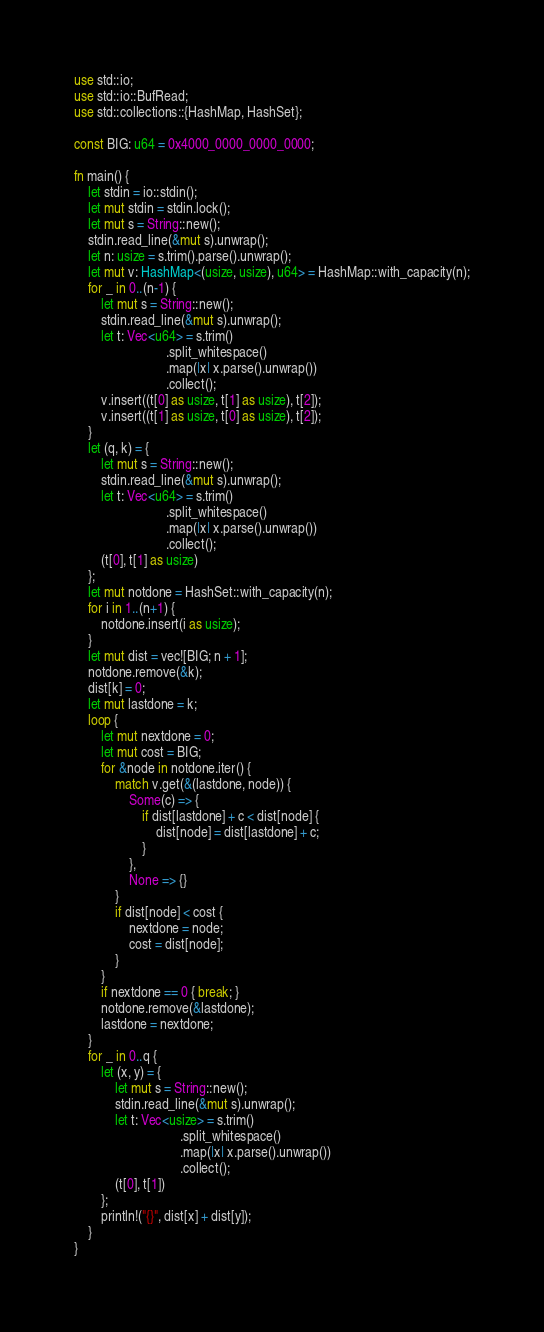Convert code to text. <code><loc_0><loc_0><loc_500><loc_500><_Rust_>use std::io;
use std::io::BufRead;
use std::collections::{HashMap, HashSet};

const BIG: u64 = 0x4000_0000_0000_0000;

fn main() {
    let stdin = io::stdin();
    let mut stdin = stdin.lock();
    let mut s = String::new();
    stdin.read_line(&mut s).unwrap();
    let n: usize = s.trim().parse().unwrap();
    let mut v: HashMap<(usize, usize), u64> = HashMap::with_capacity(n);
    for _ in 0..(n-1) {
        let mut s = String::new();
        stdin.read_line(&mut s).unwrap();
        let t: Vec<u64> = s.trim()
                           .split_whitespace()
                           .map(|x| x.parse().unwrap())
                           .collect();
        v.insert((t[0] as usize, t[1] as usize), t[2]);
        v.insert((t[1] as usize, t[0] as usize), t[2]);
    }
    let (q, k) = {
        let mut s = String::new();
        stdin.read_line(&mut s).unwrap();
        let t: Vec<u64> = s.trim()
                           .split_whitespace()
                           .map(|x| x.parse().unwrap())
                           .collect();
        (t[0], t[1] as usize)
    };
    let mut notdone = HashSet::with_capacity(n);
    for i in 1..(n+1) {
        notdone.insert(i as usize);
    }
    let mut dist = vec![BIG; n + 1];
    notdone.remove(&k);
    dist[k] = 0;
    let mut lastdone = k;
    loop {
        let mut nextdone = 0;
        let mut cost = BIG;
        for &node in notdone.iter() {
            match v.get(&(lastdone, node)) {
                Some(c) => {
                    if dist[lastdone] + c < dist[node] {
                        dist[node] = dist[lastdone] + c;
                    }
                },
                None => {}
            }
            if dist[node] < cost {
                nextdone = node;
                cost = dist[node];
            }
        }
        if nextdone == 0 { break; }
        notdone.remove(&lastdone);
        lastdone = nextdone;
    }
    for _ in 0..q {
        let (x, y) = {
            let mut s = String::new();
            stdin.read_line(&mut s).unwrap();
            let t: Vec<usize> = s.trim()
                               .split_whitespace()
                               .map(|x| x.parse().unwrap())
                               .collect();
            (t[0], t[1])
        };
        println!("{}", dist[x] + dist[y]);
    }
}
</code> 